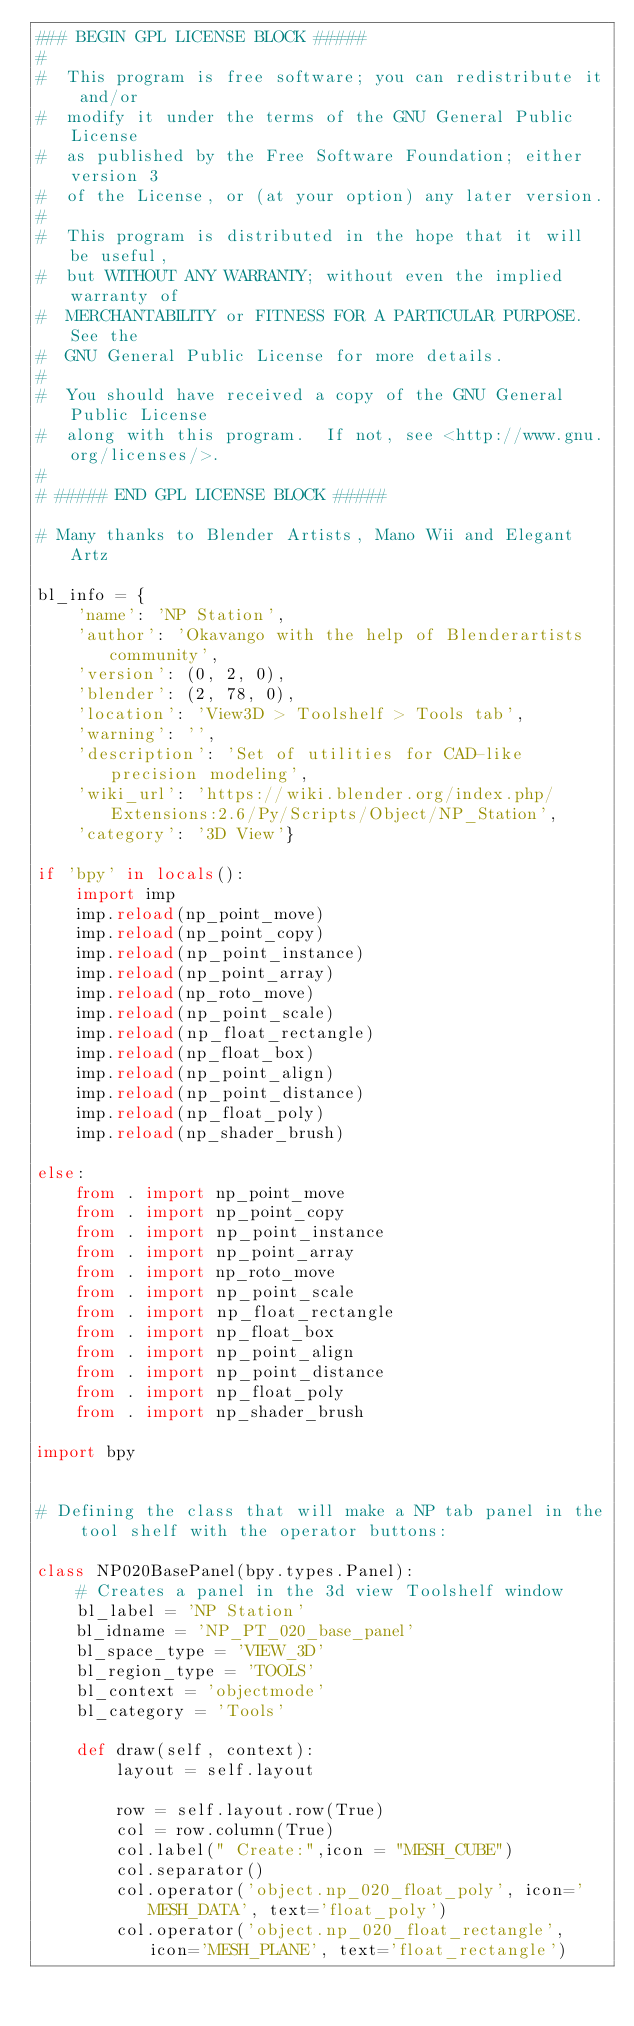<code> <loc_0><loc_0><loc_500><loc_500><_Python_>### BEGIN GPL LICENSE BLOCK #####
#
#  This program is free software; you can redistribute it and/or
#  modify it under the terms of the GNU General Public License
#  as published by the Free Software Foundation; either version 3
#  of the License, or (at your option) any later version.
#
#  This program is distributed in the hope that it will be useful,
#  but WITHOUT ANY WARRANTY; without even the implied warranty of
#  MERCHANTABILITY or FITNESS FOR A PARTICULAR PURPOSE.  See the
#  GNU General Public License for more details.
#
#  You should have received a copy of the GNU General Public License
#  along with this program.  If not, see <http://www.gnu.org/licenses/>.
#
# ##### END GPL LICENSE BLOCK #####

# Many thanks to Blender Artists, Mano Wii and Elegant Artz

bl_info = {
    'name': 'NP Station',
    'author': 'Okavango with the help of Blenderartists community',
    'version': (0, 2, 0),
    'blender': (2, 78, 0),
    'location': 'View3D > Toolshelf > Tools tab',
    'warning': '',
    'description': 'Set of utilities for CAD-like precision modeling',
    'wiki_url': 'https://wiki.blender.org/index.php/Extensions:2.6/Py/Scripts/Object/NP_Station',
    'category': '3D View'}

if 'bpy' in locals():
    import imp
    imp.reload(np_point_move)
    imp.reload(np_point_copy)
    imp.reload(np_point_instance)
    imp.reload(np_point_array)
    imp.reload(np_roto_move)
    imp.reload(np_point_scale)
    imp.reload(np_float_rectangle)
    imp.reload(np_float_box)
    imp.reload(np_point_align)
    imp.reload(np_point_distance)
    imp.reload(np_float_poly)
    imp.reload(np_shader_brush)

else:
    from . import np_point_move
    from . import np_point_copy
    from . import np_point_instance
    from . import np_point_array
    from . import np_roto_move
    from . import np_point_scale
    from . import np_float_rectangle
    from . import np_float_box
    from . import np_point_align
    from . import np_point_distance
    from . import np_float_poly
    from . import np_shader_brush

import bpy


# Defining the class that will make a NP tab panel in the tool shelf with the operator buttons:

class NP020BasePanel(bpy.types.Panel):
    # Creates a panel in the 3d view Toolshelf window
    bl_label = 'NP Station'
    bl_idname = 'NP_PT_020_base_panel'
    bl_space_type = 'VIEW_3D'
    bl_region_type = 'TOOLS'
    bl_context = 'objectmode'
    bl_category = 'Tools'

    def draw(self, context):
        layout = self.layout

        row = self.layout.row(True)
        col = row.column(True)
        col.label(" Create:",icon = "MESH_CUBE")
        col.separator()
        col.operator('object.np_020_float_poly', icon='MESH_DATA', text='float_poly')
        col.operator('object.np_020_float_rectangle', icon='MESH_PLANE', text='float_rectangle')</code> 